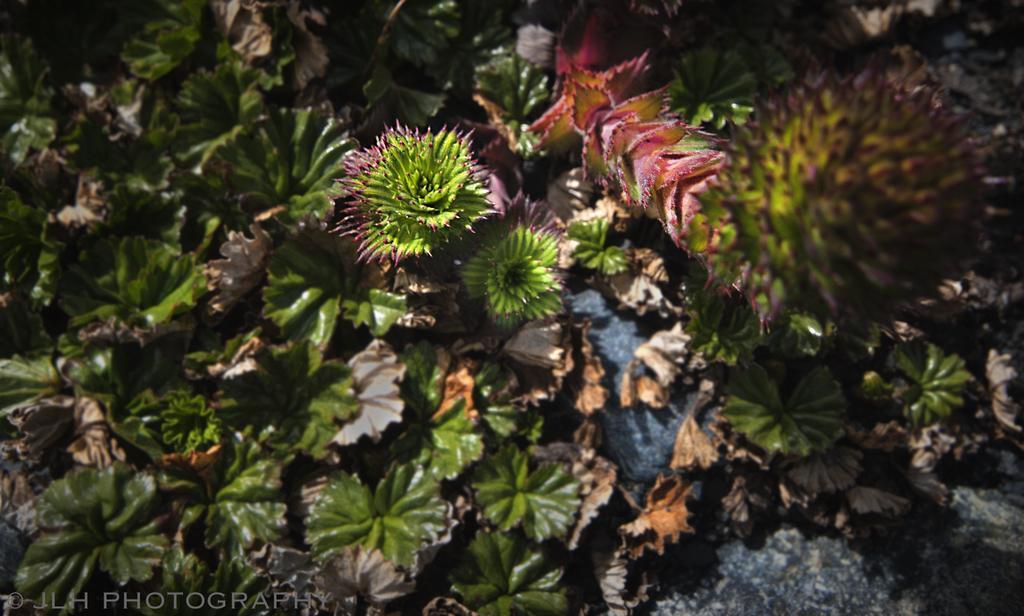Describe this image in one or two sentences. In this picture we can see plants, leaves and rock. In the bottom left side of the image we can see text. 